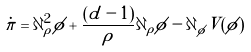<formula> <loc_0><loc_0><loc_500><loc_500>\dot { \pi } = \partial _ { \rho } ^ { 2 } \phi + \frac { ( d - 1 ) } { \rho } \partial _ { \rho } \phi - \partial _ { \phi } V ( \phi )</formula> 